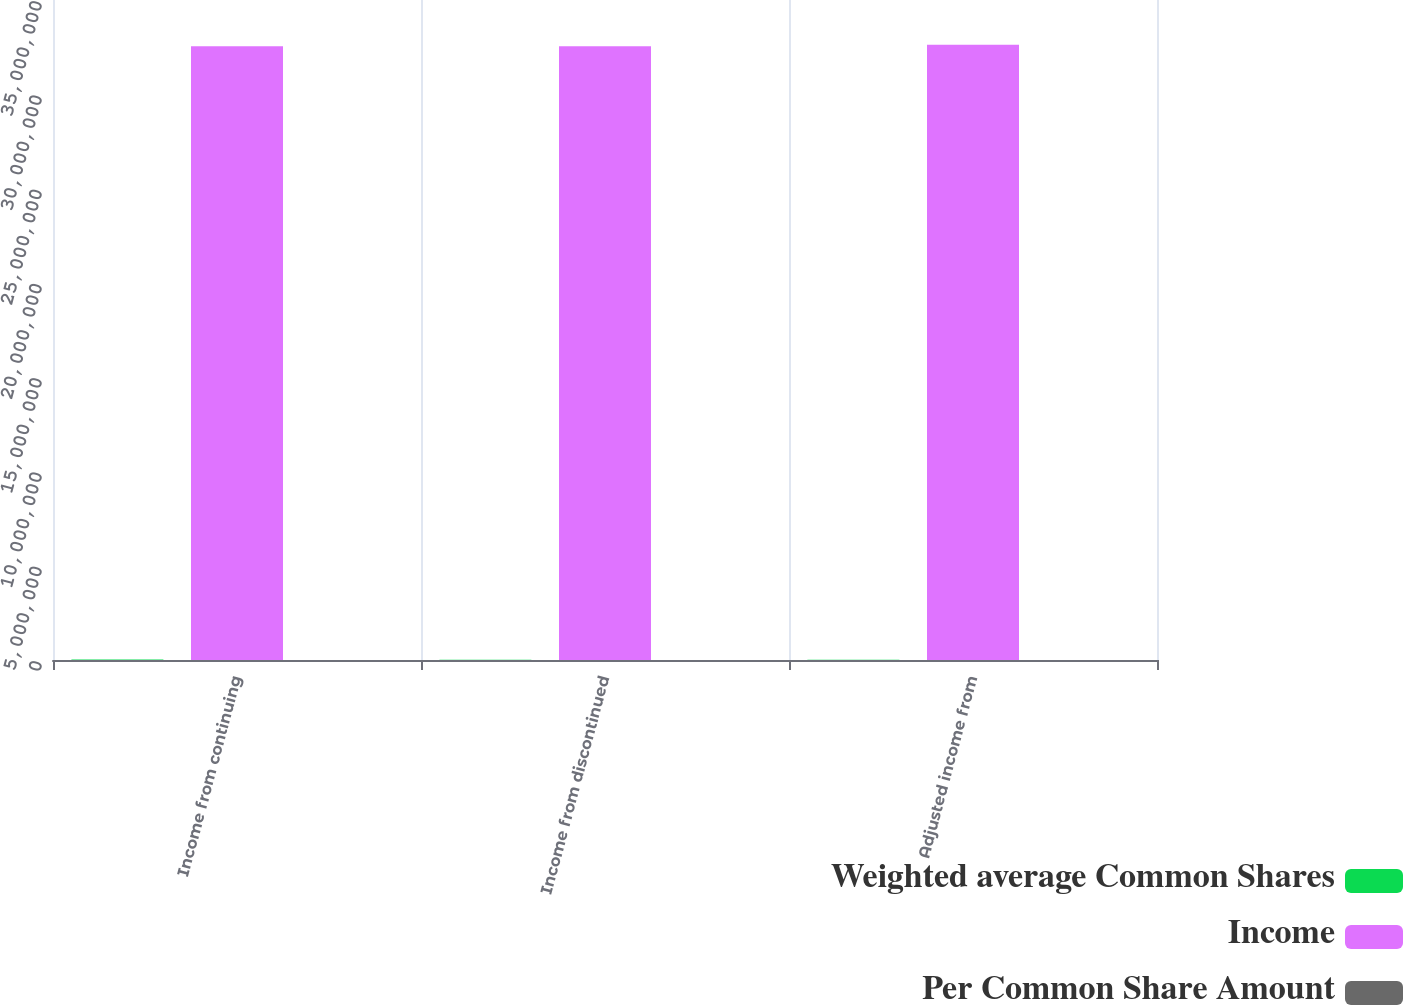<chart> <loc_0><loc_0><loc_500><loc_500><stacked_bar_chart><ecel><fcel>Income from continuing<fcel>Income from discontinued<fcel>Adjusted income from<nl><fcel>Weighted average Common Shares<fcel>33130<fcel>7238<fcel>7238<nl><fcel>Income<fcel>3.25418e+07<fcel>3.25418e+07<fcel>3.26287e+07<nl><fcel>Per Common Share Amount<fcel>1.02<fcel>0.22<fcel>0.22<nl></chart> 